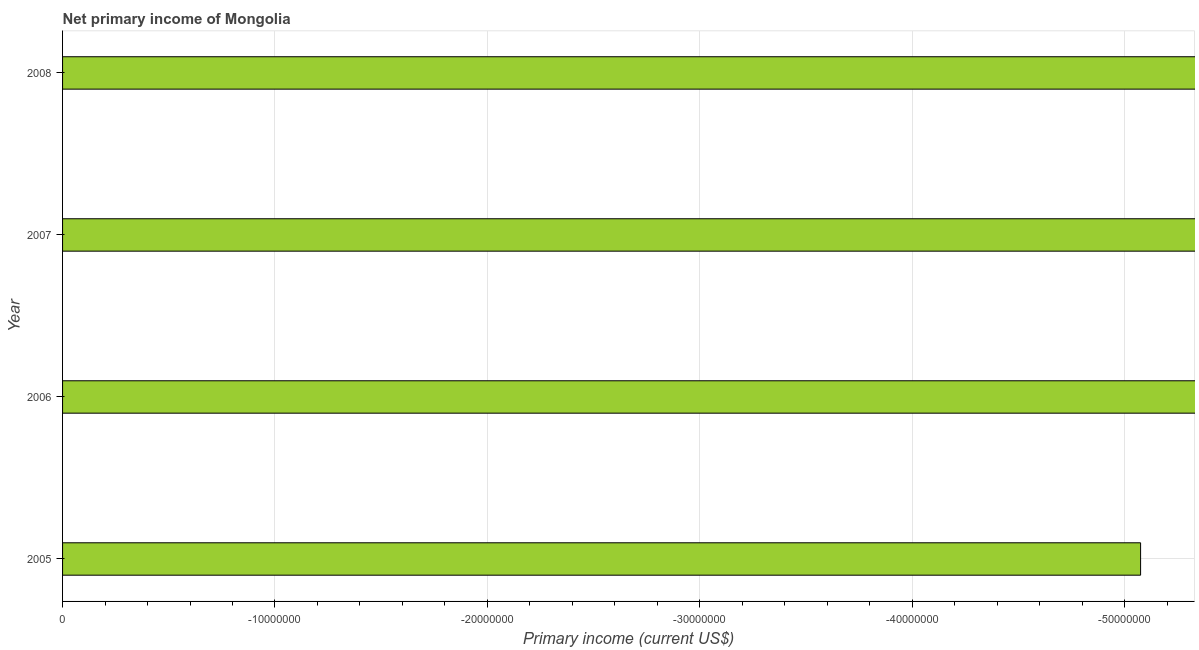Does the graph contain grids?
Keep it short and to the point. Yes. What is the title of the graph?
Provide a short and direct response. Net primary income of Mongolia. What is the label or title of the X-axis?
Offer a very short reply. Primary income (current US$). What is the average amount of primary income per year?
Give a very brief answer. 0. In how many years, is the amount of primary income greater than -20000000 US$?
Ensure brevity in your answer.  0. In how many years, is the amount of primary income greater than the average amount of primary income taken over all years?
Offer a very short reply. 0. How many bars are there?
Give a very brief answer. 0. Are all the bars in the graph horizontal?
Make the answer very short. Yes. What is the difference between two consecutive major ticks on the X-axis?
Provide a succinct answer. 1.00e+07. Are the values on the major ticks of X-axis written in scientific E-notation?
Your answer should be compact. No. What is the Primary income (current US$) in 2007?
Offer a terse response. 0. 